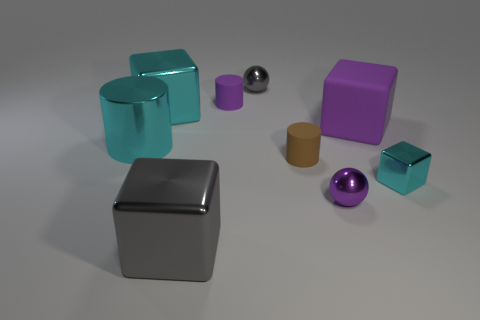Subtract all yellow balls. How many cyan cubes are left? 2 Subtract 1 cylinders. How many cylinders are left? 2 Subtract all tiny cubes. How many cubes are left? 3 Subtract all purple cubes. How many cubes are left? 3 Add 1 cyan balls. How many objects exist? 10 Subtract all green cubes. Subtract all brown cylinders. How many cubes are left? 4 Subtract all cylinders. How many objects are left? 6 Subtract all large brown spheres. Subtract all large gray metal blocks. How many objects are left? 8 Add 6 shiny blocks. How many shiny blocks are left? 9 Add 5 small purple cylinders. How many small purple cylinders exist? 6 